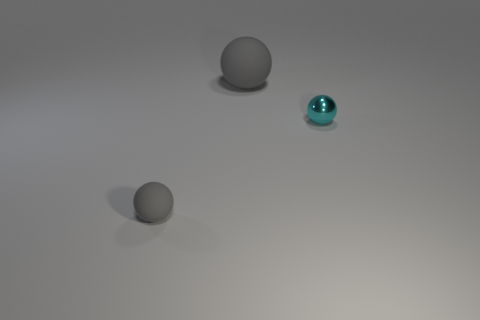Subtract all tiny cyan metal balls. How many balls are left? 2 Subtract all cyan balls. How many balls are left? 2 Subtract 0 gray blocks. How many objects are left? 3 Subtract all blue balls. Subtract all cyan cylinders. How many balls are left? 3 Subtract all red cylinders. How many green spheres are left? 0 Subtract all big gray spheres. Subtract all tiny cyan metallic things. How many objects are left? 1 Add 3 tiny gray spheres. How many tiny gray spheres are left? 4 Add 2 shiny objects. How many shiny objects exist? 3 Add 1 blue rubber things. How many objects exist? 4 